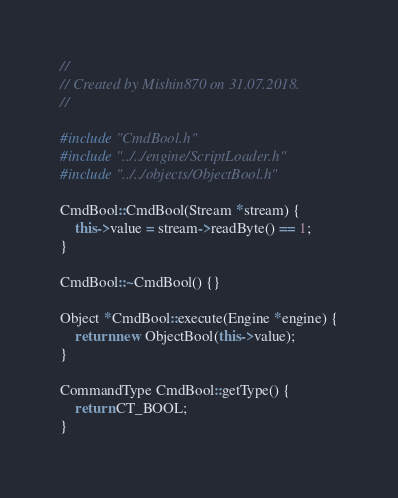<code> <loc_0><loc_0><loc_500><loc_500><_C++_>//
// Created by Mishin870 on 31.07.2018.
//

#include "CmdBool.h"
#include "../../engine/ScriptLoader.h"
#include "../../objects/ObjectBool.h"

CmdBool::CmdBool(Stream *stream) {
	this->value = stream->readByte() == 1;
}

CmdBool::~CmdBool() {}

Object *CmdBool::execute(Engine *engine) {
	return new ObjectBool(this->value);
}

CommandType CmdBool::getType() {
	return CT_BOOL;
}
</code> 